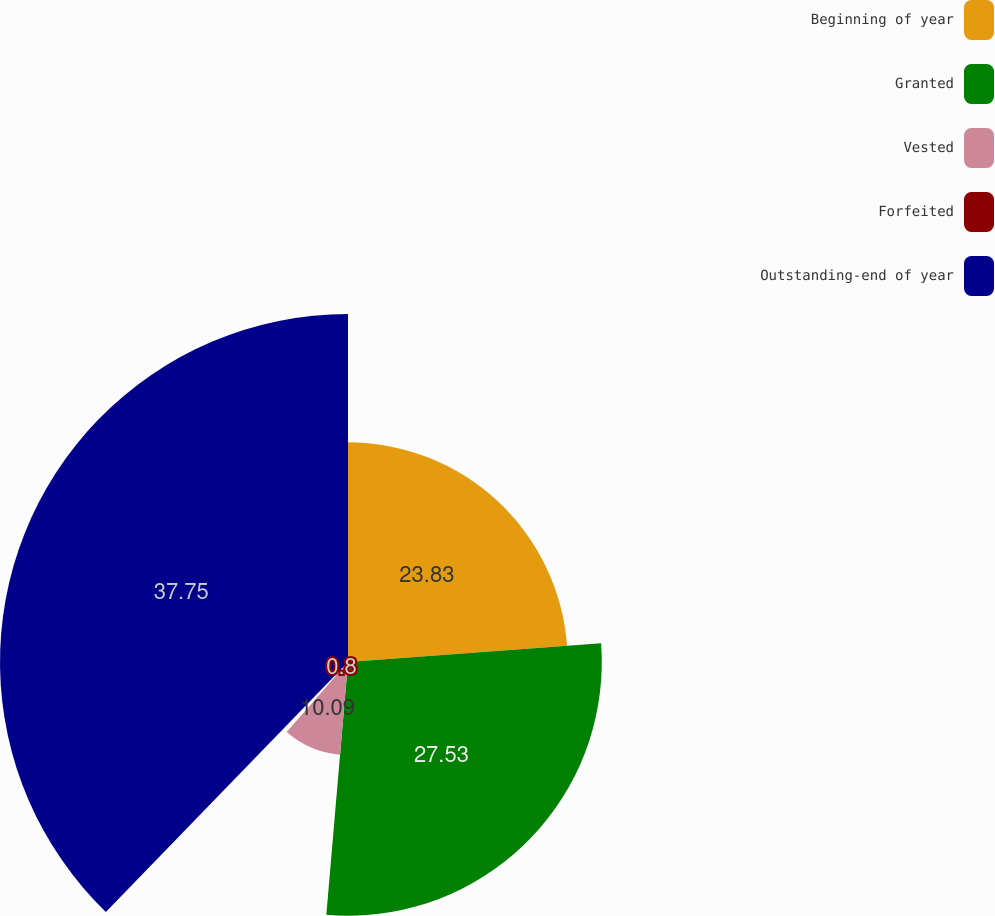<chart> <loc_0><loc_0><loc_500><loc_500><pie_chart><fcel>Beginning of year<fcel>Granted<fcel>Vested<fcel>Forfeited<fcel>Outstanding-end of year<nl><fcel>23.83%<fcel>27.53%<fcel>10.09%<fcel>0.8%<fcel>37.75%<nl></chart> 